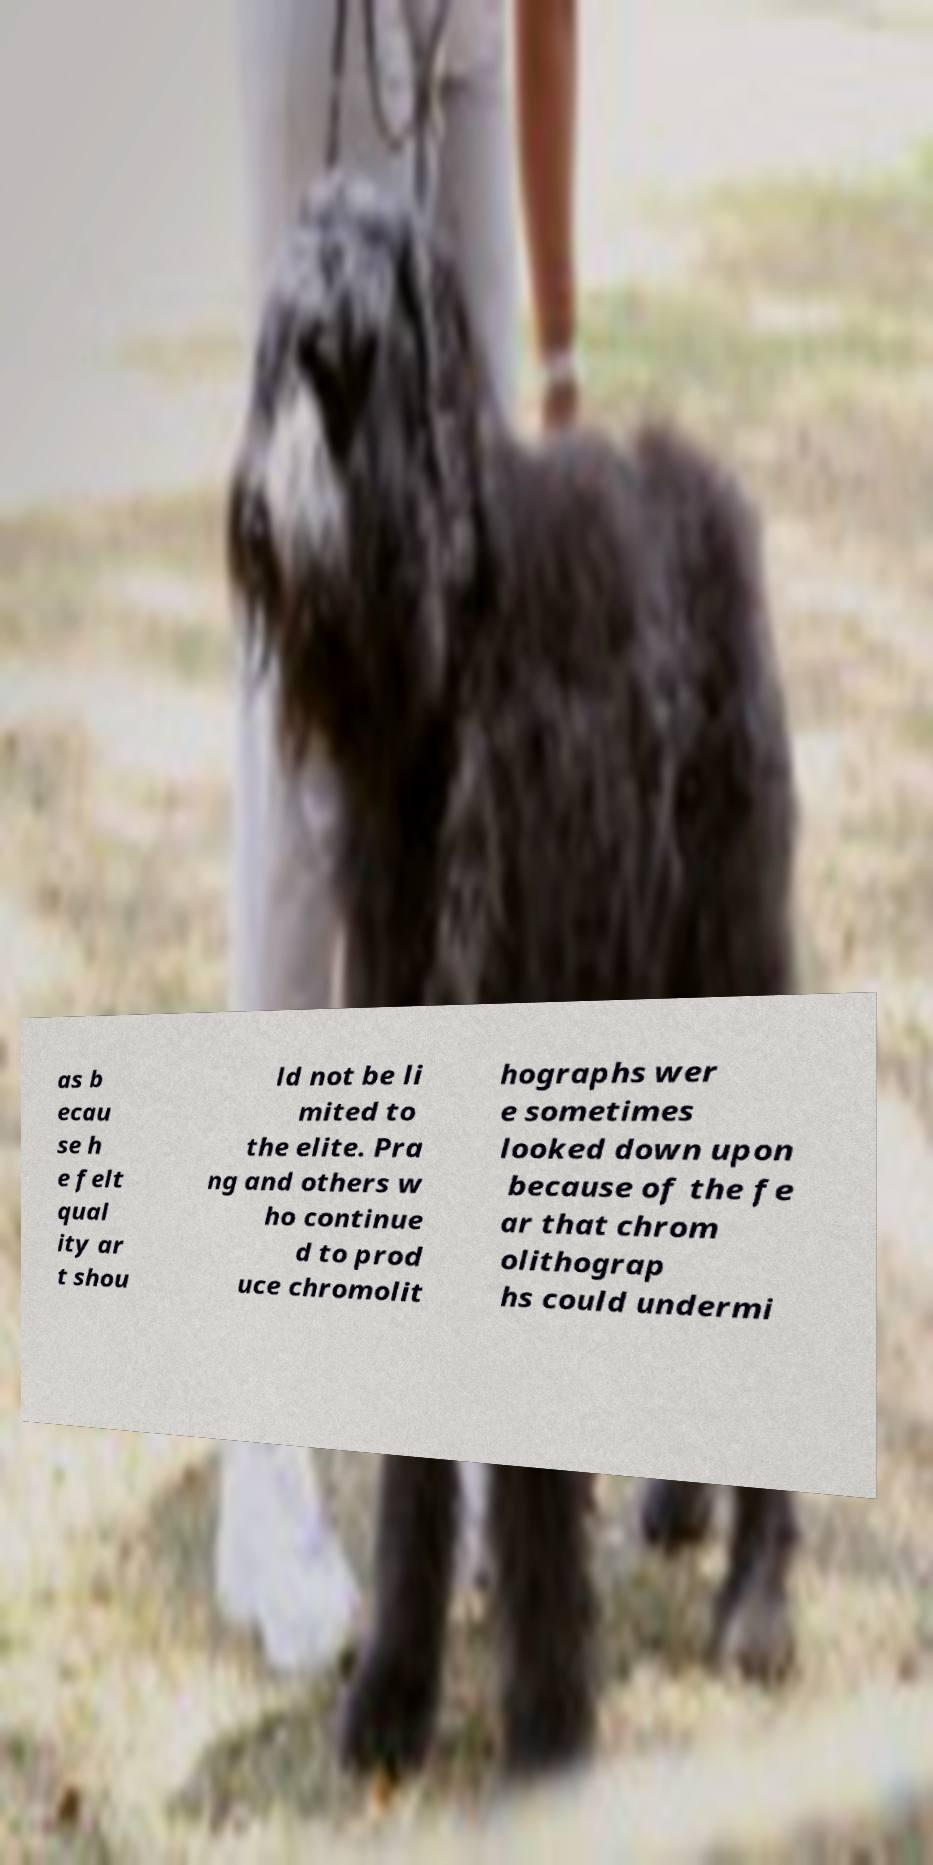Can you accurately transcribe the text from the provided image for me? as b ecau se h e felt qual ity ar t shou ld not be li mited to the elite. Pra ng and others w ho continue d to prod uce chromolit hographs wer e sometimes looked down upon because of the fe ar that chrom olithograp hs could undermi 